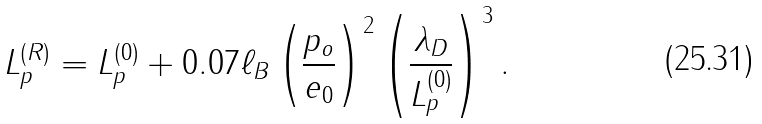<formula> <loc_0><loc_0><loc_500><loc_500>L _ { p } ^ { ( R ) } = L _ { p } ^ { ( 0 ) } + 0 . 0 7 \ell _ { B } \left ( \frac { p _ { o } } { e _ { 0 } } \right ) ^ { 2 } \left ( \frac { \lambda _ { D } } { L _ { p } ^ { ( 0 ) } } \right ) ^ { 3 } .</formula> 